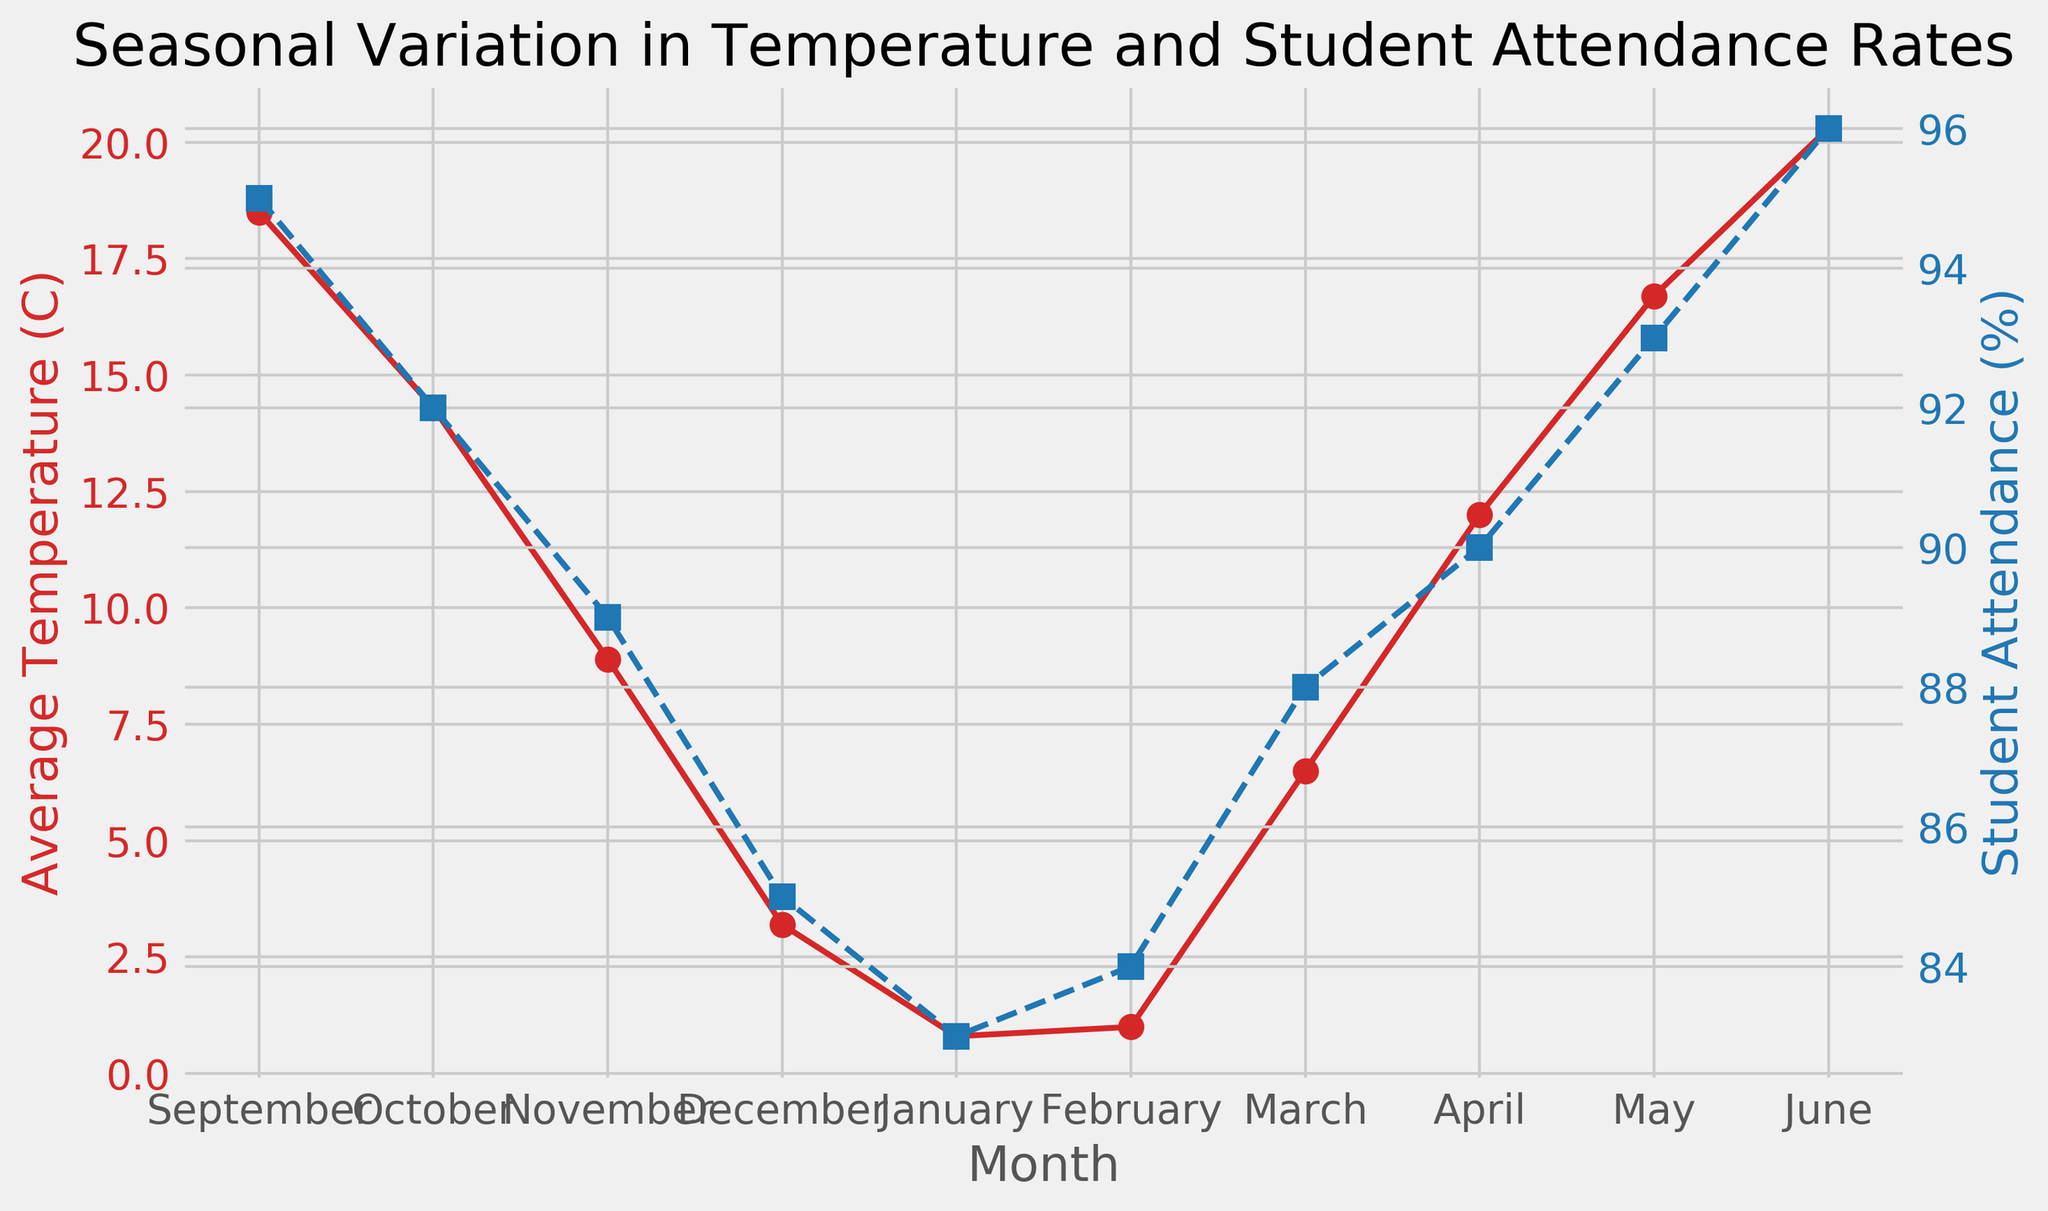Which month has the highest average temperature? By looking at the red curve representing average temperature, the highest point is in June.
Answer: June Which month has the lowest student attendance rate? By observing the blue curve representing student attendance, the lowest point is in January.
Answer: January Is there a month where the average temperature is below 5°C but the student attendance rate is above 85%? Checking the red line for temperatures below 5°C reveals December and January, but only in December is the attendance above 85%.
Answer: December What is the difference in student attendance rate between May and November? From the blue line, the attendance in May is 93%, and in November, it's 89%. The difference is 93% - 89% = 4%.
Answer: 4% How does student attendance in March compare to that in September? In March, the attendance is 88%, and in September, it is 95%. Thus, attendance is higher in September compared to March.
Answer: Higher in September When the average temperature is about 1°C, what is the student attendance rate? Looking at the red line around 1°C corresponds to February. The blue line indicates the student attendance rate for February is 84%.
Answer: 84% Which month has the greatest drop in student attendance compared to the previous month? By evaluating the blue line, the greatest drop is observed from September (95%) to October (92%), a difference of 3%.
Answer: September to October What is the average student attendance rate for the months with temperatures above 15°C? Average temperatures above 15°C are in September (95%), May (93%), and June (96%). The average attendance rate is (95% + 93% + 96%) / 3 = 94.67%.
Answer: 94.67% What is the overall trend of student attendance as the temperature decreases from September to January? Observing both curves, as the average temperature decreases from September (18.5°C) to January (0.8°C), student attendance also generally decreases from 95% to 83%.
Answer: Decreasing In which month is there the largest discrepancy between the average temperature and student attendance rate? The largest discrepancy can be identified where the red and blue lines are the farthest apart. This occurs in June, with a temperature of 20.3°C and attendance rate of 96%.
Answer: June 